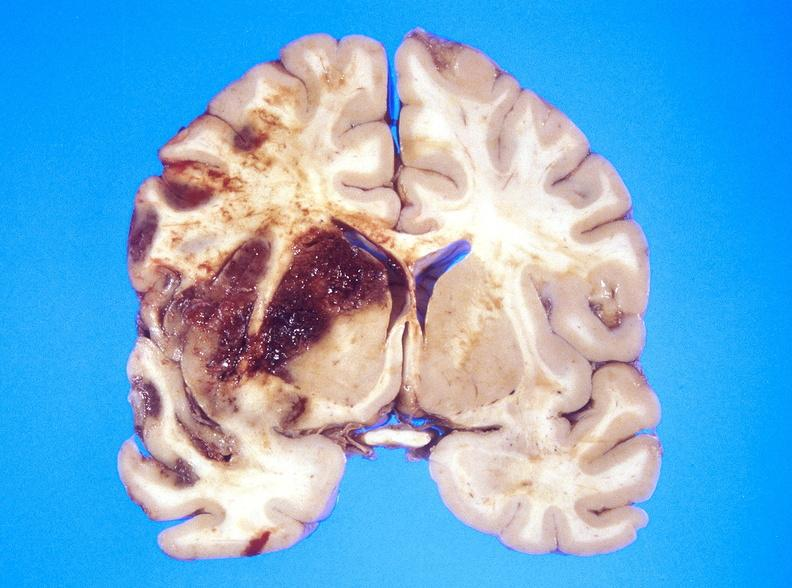s amputation stump infected present?
Answer the question using a single word or phrase. No 